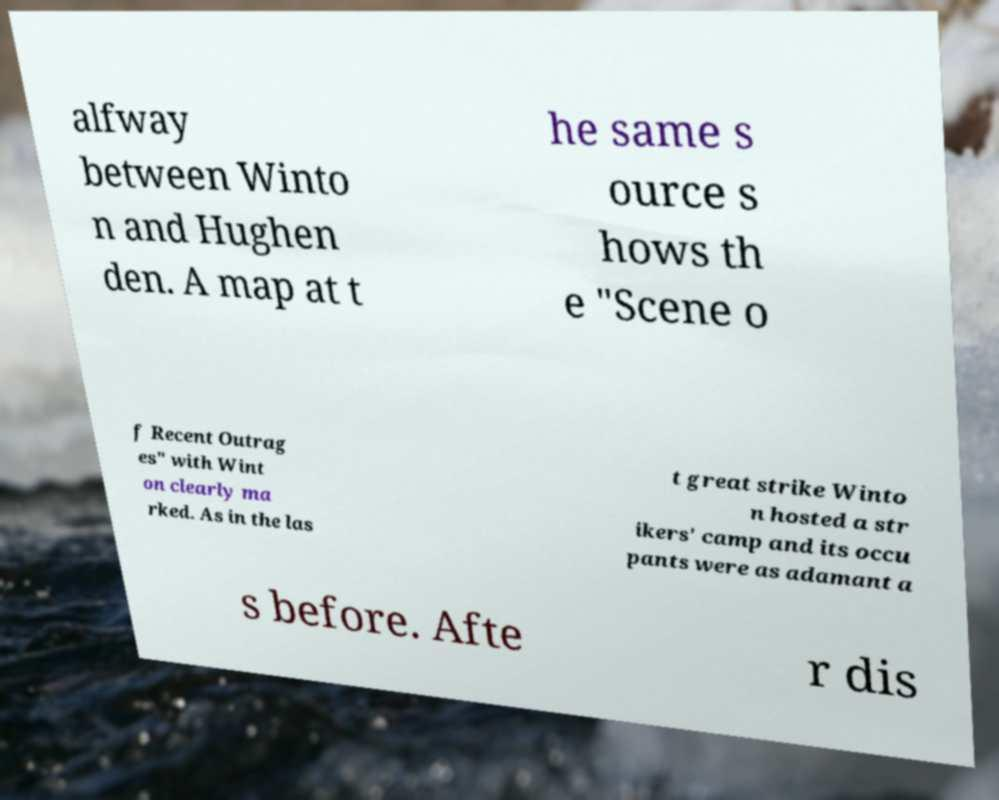There's text embedded in this image that I need extracted. Can you transcribe it verbatim? alfway between Winto n and Hughen den. A map at t he same s ource s hows th e "Scene o f Recent Outrag es" with Wint on clearly ma rked. As in the las t great strike Winto n hosted a str ikers' camp and its occu pants were as adamant a s before. Afte r dis 